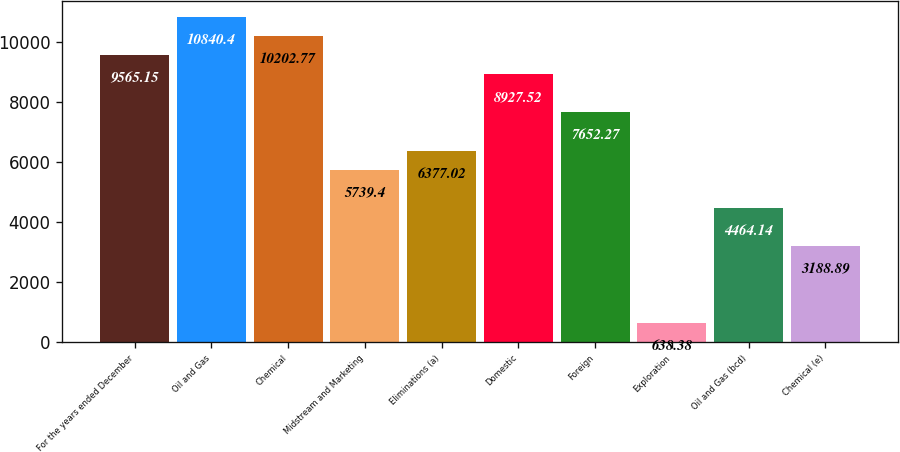Convert chart to OTSL. <chart><loc_0><loc_0><loc_500><loc_500><bar_chart><fcel>For the years ended December<fcel>Oil and Gas<fcel>Chemical<fcel>Midstream and Marketing<fcel>Eliminations (a)<fcel>Domestic<fcel>Foreign<fcel>Exploration<fcel>Oil and Gas (bcd)<fcel>Chemical (e)<nl><fcel>9565.15<fcel>10840.4<fcel>10202.8<fcel>5739.4<fcel>6377.02<fcel>8927.52<fcel>7652.27<fcel>638.38<fcel>4464.14<fcel>3188.89<nl></chart> 